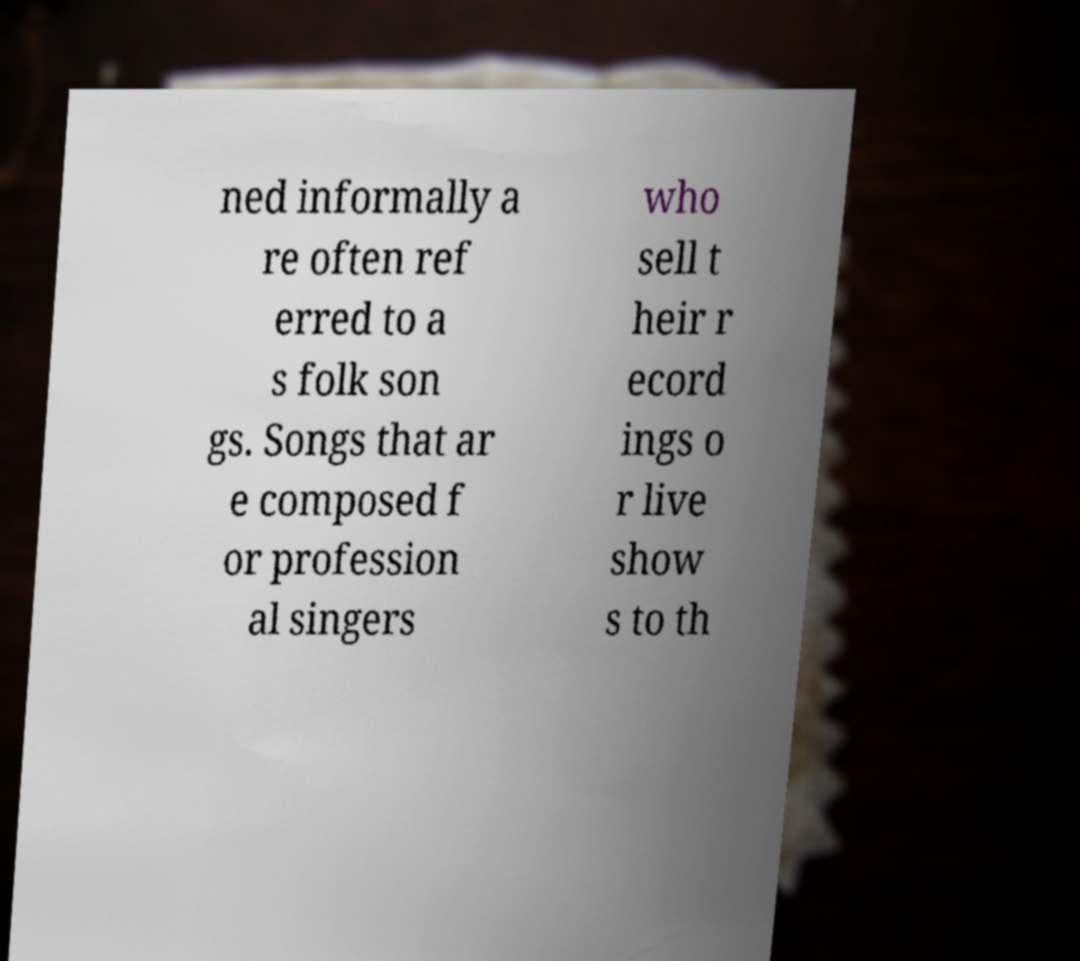Can you accurately transcribe the text from the provided image for me? ned informally a re often ref erred to a s folk son gs. Songs that ar e composed f or profession al singers who sell t heir r ecord ings o r live show s to th 